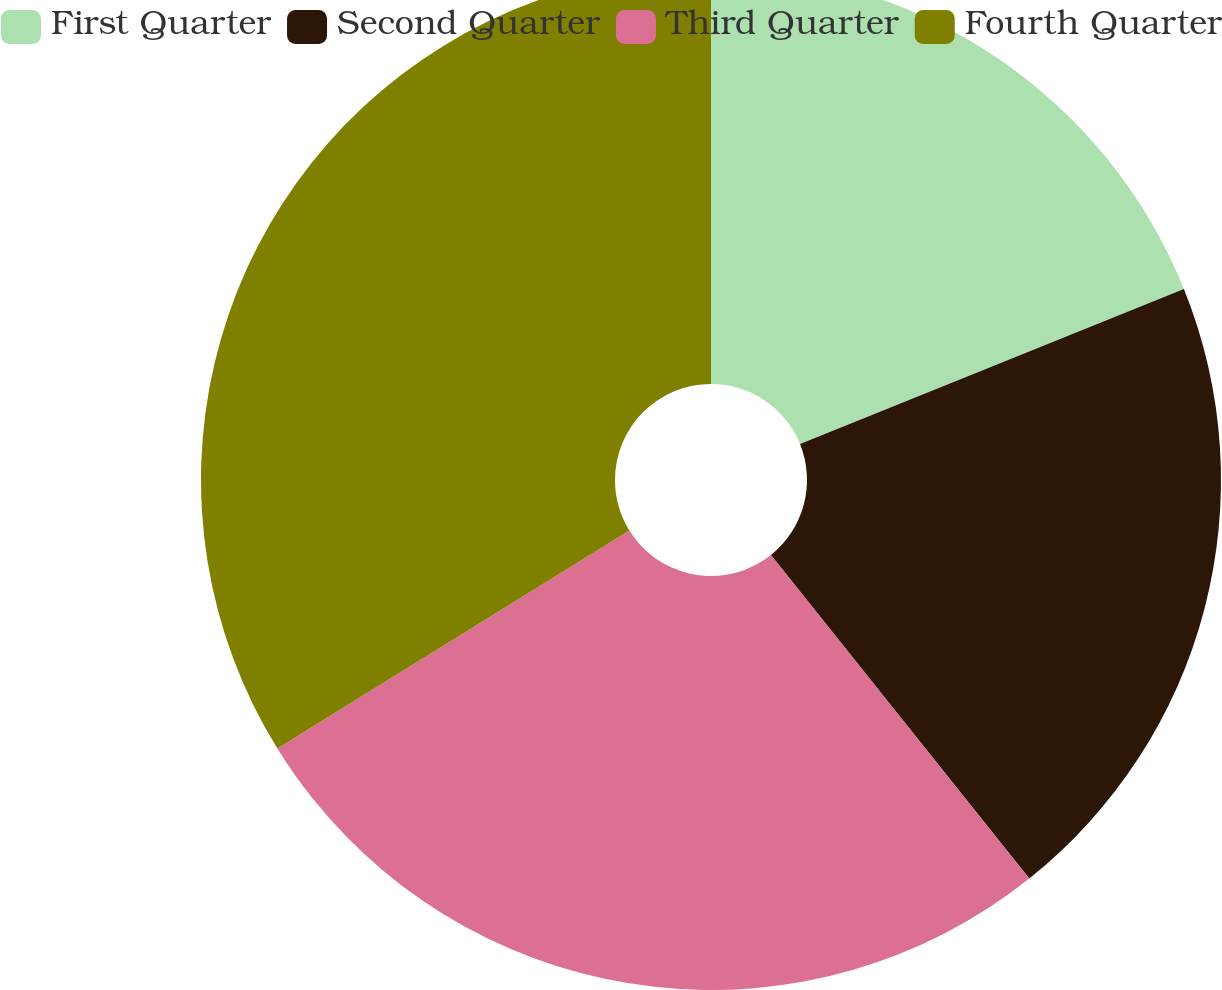Convert chart. <chart><loc_0><loc_0><loc_500><loc_500><pie_chart><fcel>First Quarter<fcel>Second Quarter<fcel>Third Quarter<fcel>Fourth Quarter<nl><fcel>18.89%<fcel>20.38%<fcel>26.9%<fcel>33.82%<nl></chart> 